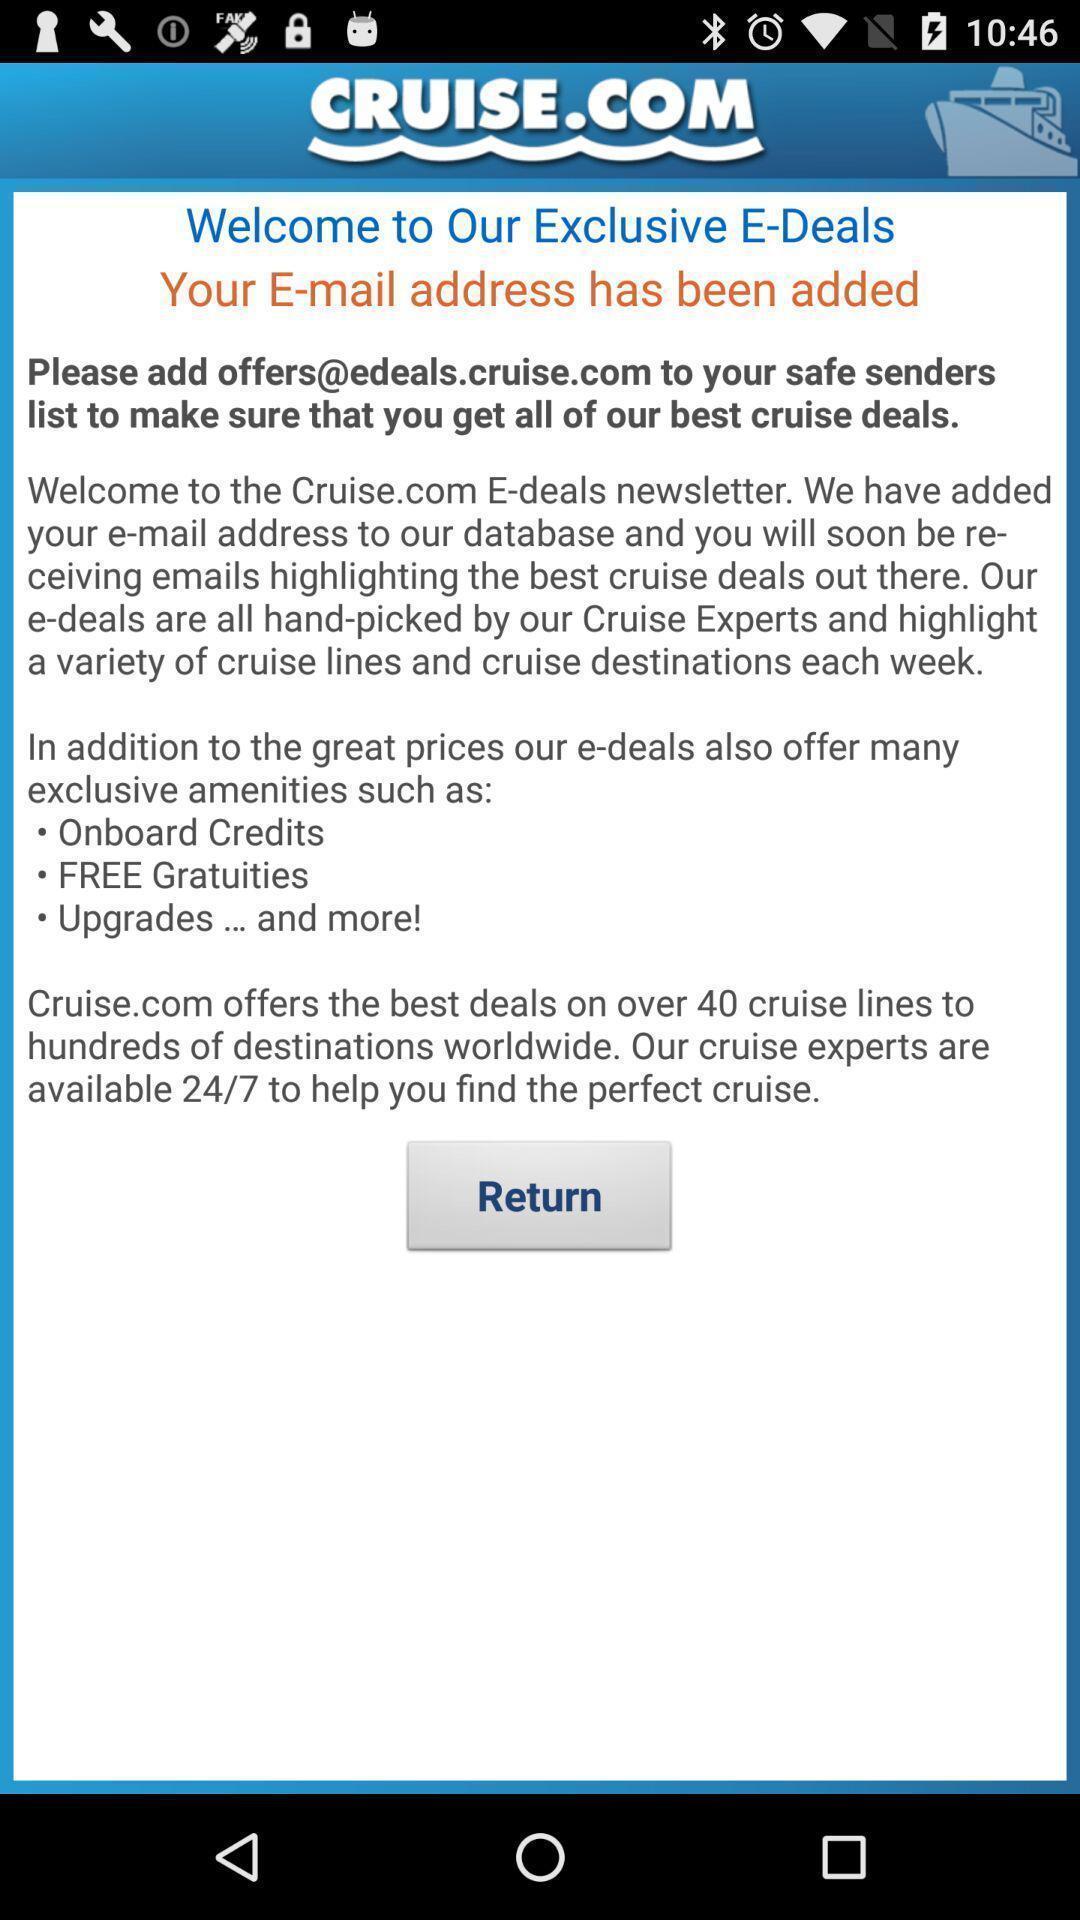What details can you identify in this image? Welcome page. 